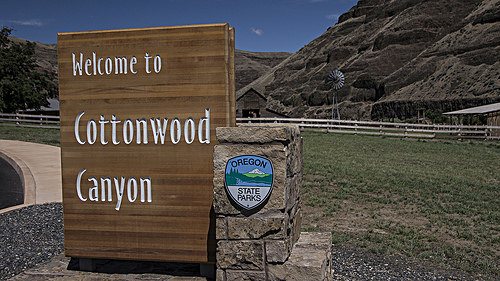<image>
Is there a windmill in front of the fence? No. The windmill is not in front of the fence. The spatial positioning shows a different relationship between these objects. 